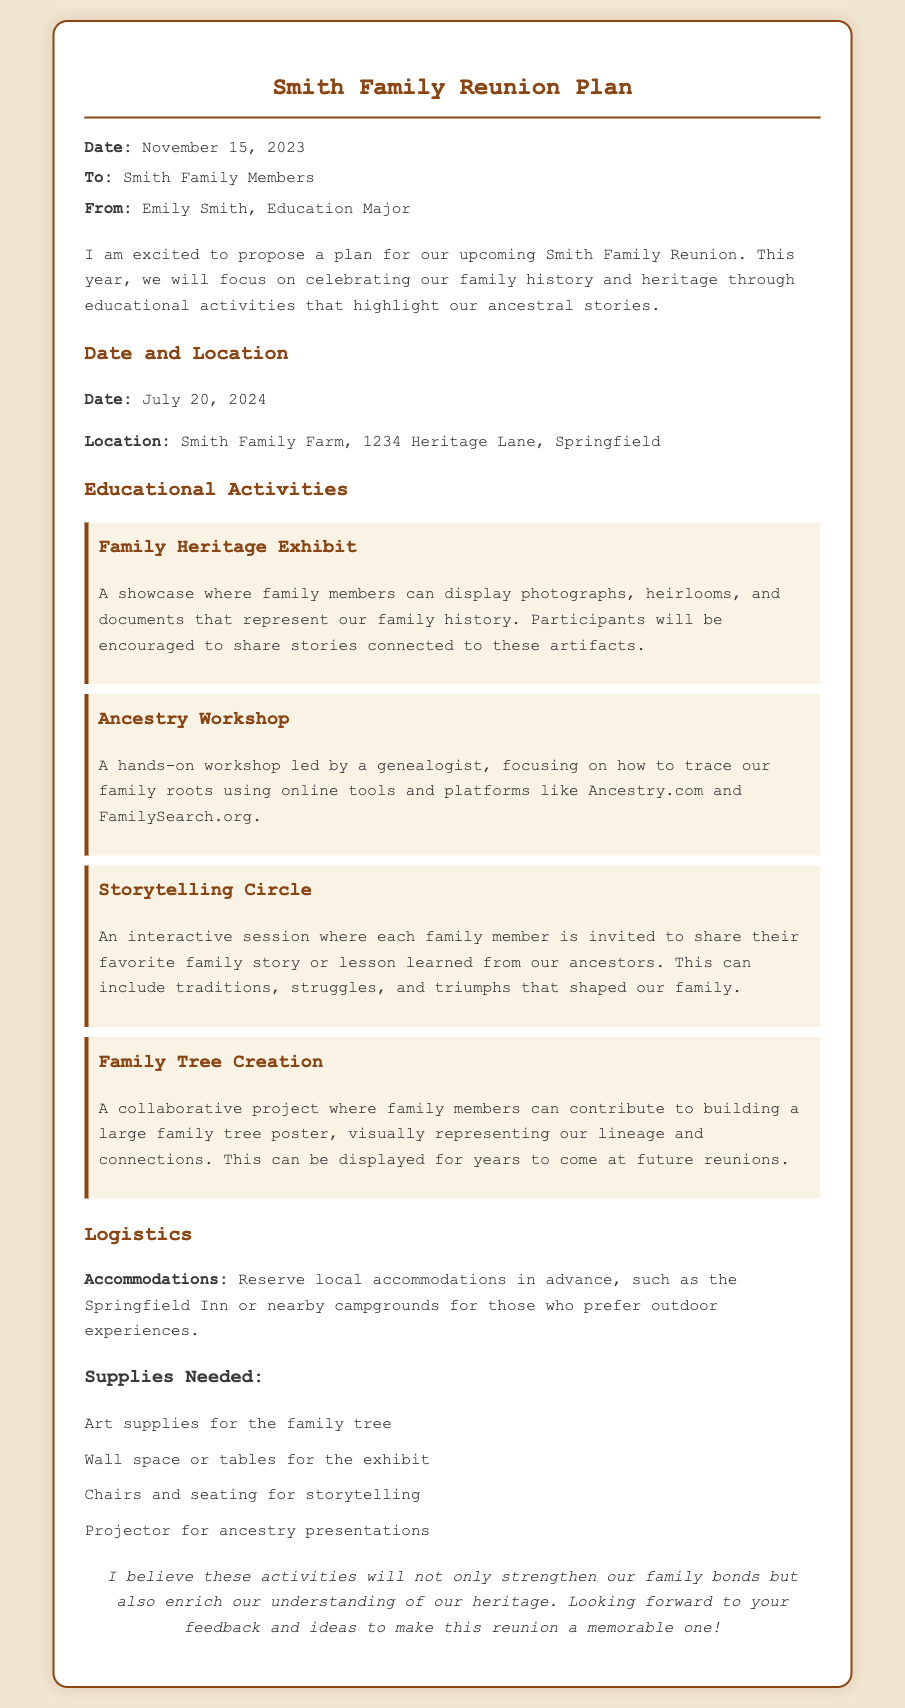What is the date of the reunion? The date of the reunion is mentioned in the document as July 20, 2024.
Answer: July 20, 2024 Who is the author of the memo? The author of the memo is specified at the top as Emily Smith.
Answer: Emily Smith What is one of the educational activities planned for the reunion? The document lists various activities including the "Family Heritage Exhibit."
Answer: Family Heritage Exhibit What supplies are needed for the family tree activity? The document mentions "Art supplies for the family tree" as one of the supplies needed.
Answer: Art supplies for the family tree How will family members participate in the Ancestry Workshop? The Ancestry Workshop is described as a hands-on workshop led by a genealogist.
Answer: Led by a genealogist What type of stories will be shared in the Storytelling Circle? The Storytelling Circle invites members to share their favorite family story or lesson learned from ancestors.
Answer: Family story or lesson learned Where is the location of the family reunion? The location of the reunion is indicated as Smith Family Farm, 1234 Heritage Lane, Springfield.
Answer: Smith Family Farm, 1234 Heritage Lane, Springfield What accommodations are suggested for the reunion? The memo suggests reserving local accommodations like the Springfield Inn.
Answer: Springfield Inn 